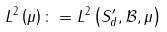<formula> <loc_0><loc_0><loc_500><loc_500>L ^ { 2 } \left ( \mu \right ) \colon = L ^ { 2 } \left ( S _ { d } ^ { \prime } , \mathcal { B } , \mu \right )</formula> 